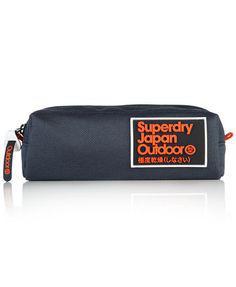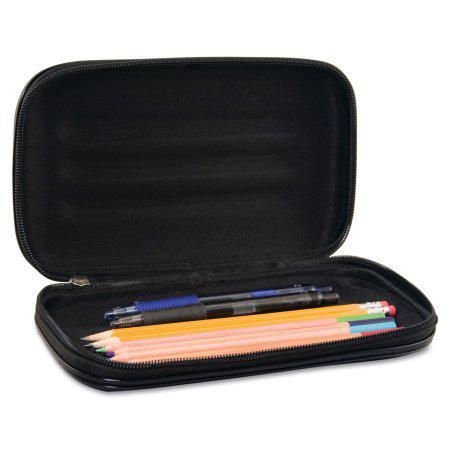The first image is the image on the left, the second image is the image on the right. For the images shown, is this caption "Some of the cases contain long yellow pencils." true? Answer yes or no. Yes. 